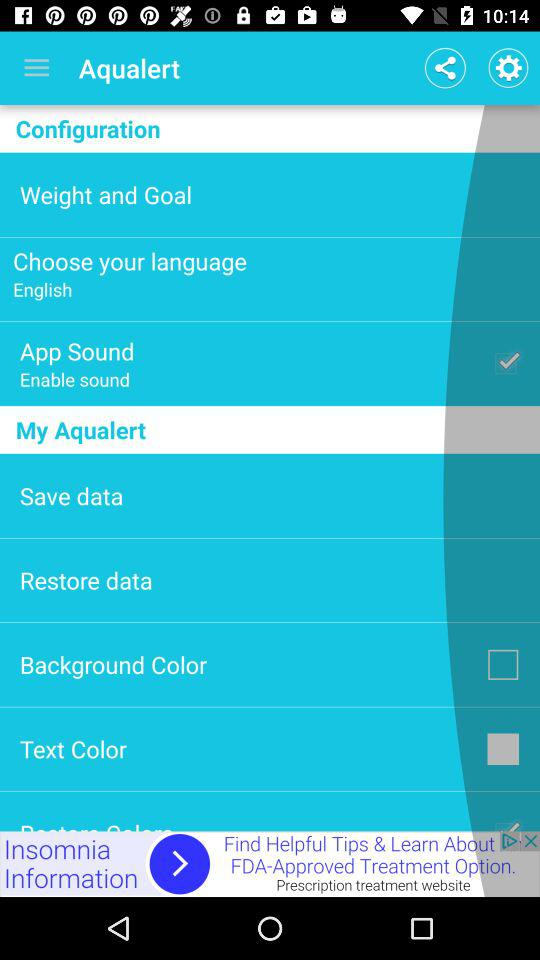Which are the selected checkboxes? The selected checkboxes are "App Sound" and "Text Color". 